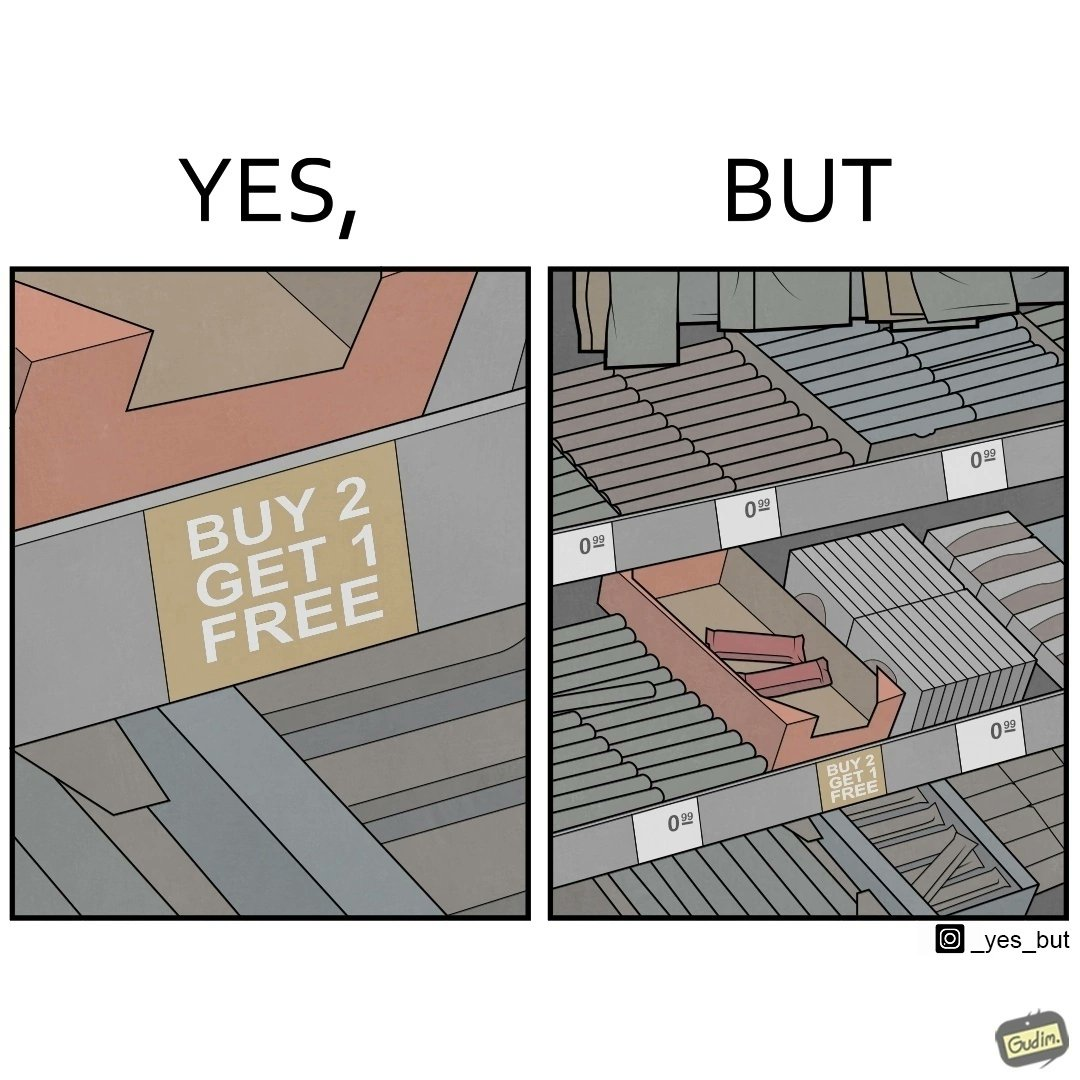Describe what you see in this image. The image is funny because while there is an offer that lets the buyer have a free item if they buy two items of the product, there is only two units left which means that the buyer won't get the free unit. 